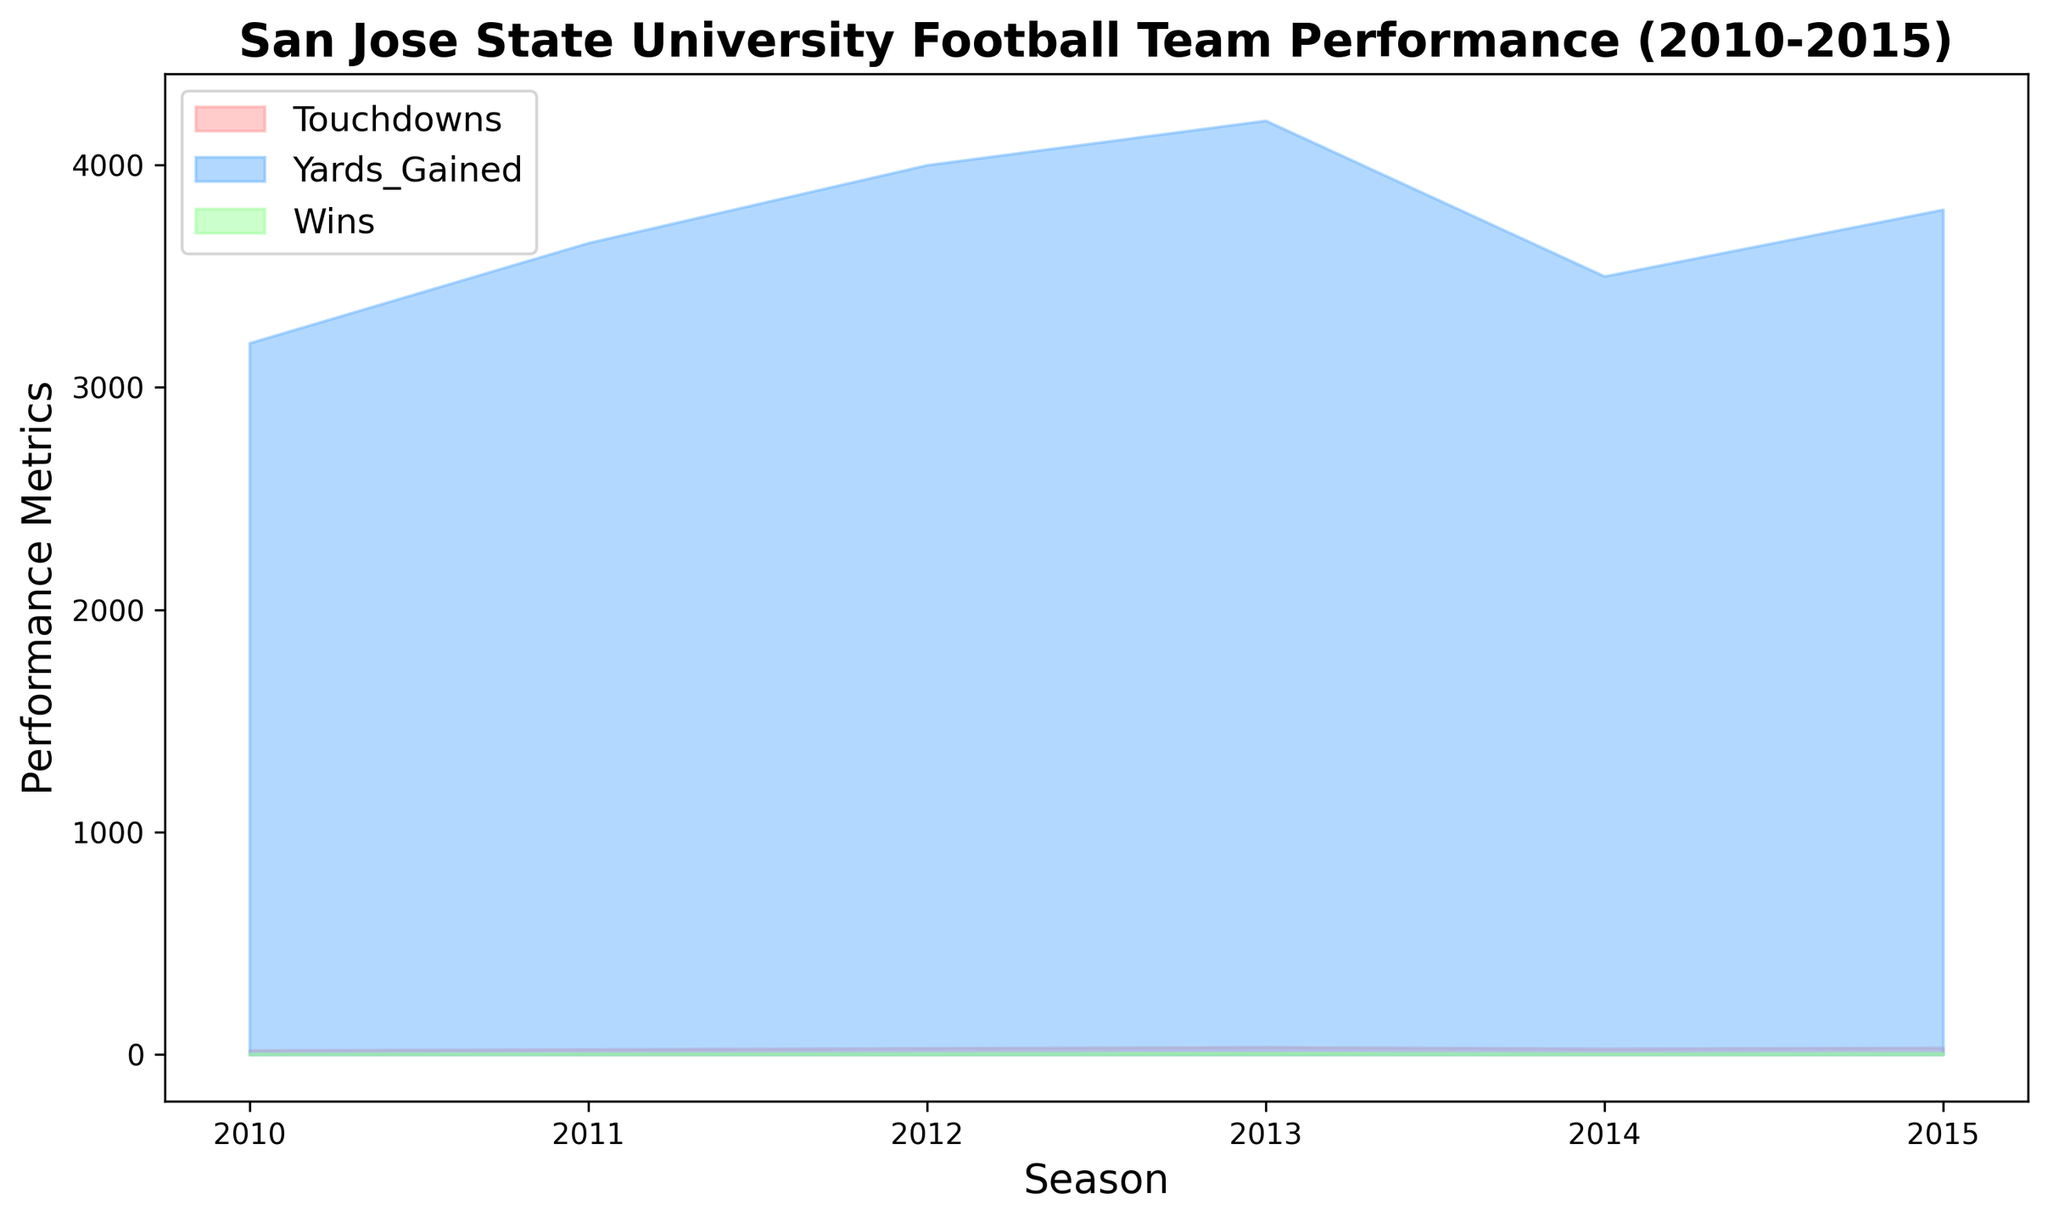What season had the highest number of wins? By observing the peaks of the green fill on the area chart that represent wins, the highest point is in 2013, indicating that it is the season with the highest number of wins.
Answer: 2013 What is the difference in the number of touchdowns between 2012 and 2014? Locate the heights of the red fills for touchdowns in both 2012 and 2014. The number of touchdowns in 2012 is 30, and in 2014 it is 28. The difference is 30 - 28 = 2.
Answer: 2 By how many yards did the team's yard gain increase from 2010 to 2013? Look at the blue fills representing yards gained in 2010 and 2013. In 2010, the yards gained is 3200, and in 2013, it is 4200. The increase is 4200 - 3200 = 1000.
Answer: 1000 What's the average number of wins from 2010 to 2015? Add all the green fill values for wins across the seasons (5, 6, 7, 9, 6, 8) and divide by the number of seasons (6). So, (5 + 6 + 7 + 9 + 6 + 8) / 6 = 41 / 6 ≈ 6.83.
Answer: 6.83 Which season had the least number of touchdowns? Compare the heights of the red fills for each season. The lowest point is in 2010, which means it had the least number of touchdowns, 20.
Answer: 2010 Are there any years where the number of touchdowns and wins both increased compared to the previous season? By observing the red and green fills for touchdowns and wins respectively, 2011 (compared to 2010) and 2015 (compared to 2014) both show an increase in touchdowns and wins.
Answer: 2011, 2015 What is the combined total number of wins in 2012 and 2013? Add the heights of the green fills for wins in 2012 and 2013. The number of wins is 7 in 2012 and 9 in 2013, thus the combined total is 7 + 9 = 16.
Answer: 16 How does the number of yards gained in 2015 compare to the number of yards gained in 2010? Check the blue fills indicating yards gained for both 2015 and 2010. In 2010, the yards gained is 3200, and in 2015 it is 3800. Since 3800 is greater than 3200, the number of yards gained in 2015 is higher.
Answer: 2015 is higher What is the proportional change in touchdowns from 2010 to 2013? Find the touchdowns in 2010 (20) and 2013 (35). The proportional change is (35 - 20) / 20 = 15 / 20 = 0.75 or 75%.
Answer: 75% Which color represents touchdowns in the chart? Observing the color fill on the area chart, touchdowns are represented by the red fill.
Answer: Red 